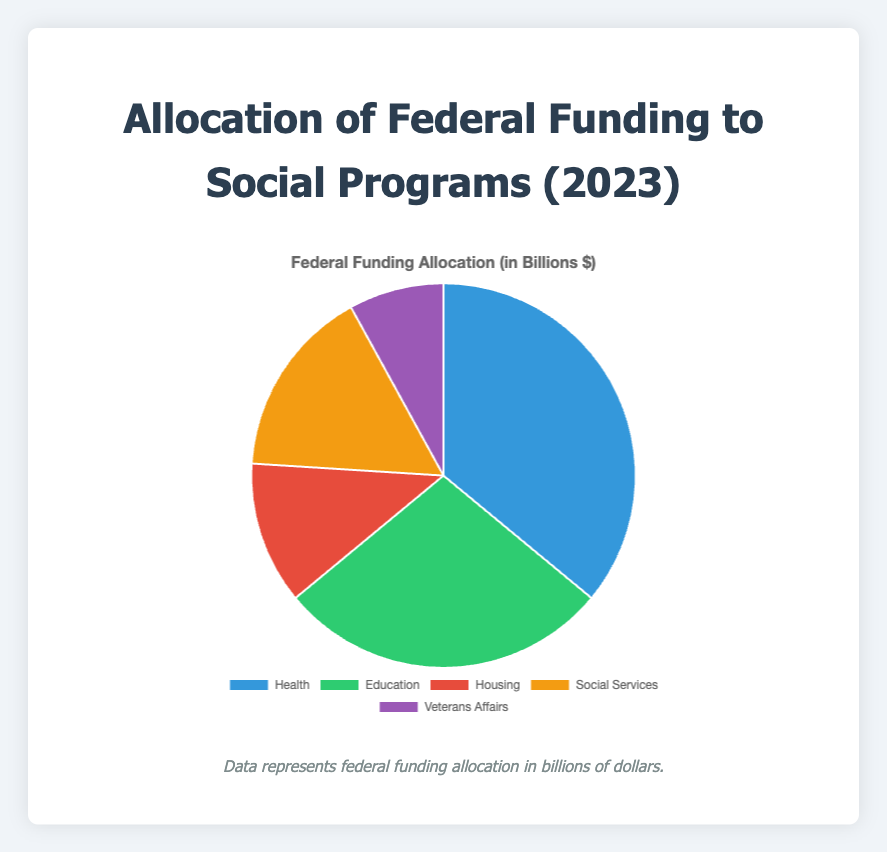How much total federal funding is allocated to Health and Education programs? According to the figure, Health programs receive $900 billion and Education programs receive $700 billion. Adding these amounts together: $900 billion + $700 billion = $1,600 billion.
Answer: $1,600 billion Which category receives the least amount of federal funding? The visual representation shows that Veterans Affairs has the smallest pie slice compared to the other categories. Therefore, Veterans Affairs receives the least funding.
Answer: Veterans Affairs Which two categories have the largest disparity in funding, and what is the amount of this disparity? The category with the highest funding is Health ($900 billion), and the category with the lowest funding is Veterans Affairs ($200 billion). The disparity can be calculated as $900 billion - $200 billion = $700 billion.
Answer: Health and Veterans Affairs, $700 billion If the total federal funding allocated to social programs is summed, what is the amount? To find the total, sum the funding for all categories: Health ($900 billion) + Education ($700 billion) + Housing ($300 billion) + Social Services ($400 billion) + Veterans Affairs ($200 billion). That is $900 + $700 + $300 + $400 + $200 = $2,500 billion.
Answer: $2,500 billion How does the funding for Social Services compare to the funding for Housing? According to the pie chart, Social Services are allocated $400 billion, whereas Housing is allocated $300 billion. Therefore, Social Services receive $100 billion more than Housing.
Answer: Social Services receive $100 billion more What percentage of the total federal funding is allocated to Education programs? First, find the total federal funding ($2,500 billion). Education receives $700 billion. The percentage is calculated as ($700 billion / $2,500 billion) * 100 = 28%.
Answer: 28% What is the difference in funding between Housing and Veterans Affairs? The chart shows that Housing receives $300 billion and Veterans Affairs receive $200 billion. The difference is $300 billion - $200 billion = $100 billion.
Answer: $100 billion Which category's pie slice is colored yellow and how much funding does it represent? The pie slice colored yellow represents the Social Services, which are allocated $400 billion.
Answer: Social Services, $400 billion Among the categories listed, which one receives the second highest amount of federal funding and what is this amount? The category receiving the highest funding is Health ($900 billion). The second highest is Education with $700 billion.
Answer: Education, $700 billion What proportion of the total federal funding is allocated to Housing and Social Services combined? Combined funding for Housing and Social Services is $300 billion + $400 billion = $700 billion. The total federal funding is $2,500 billion. The proportion is $700 billion / $2,500 billion = 28%.
Answer: 28% 